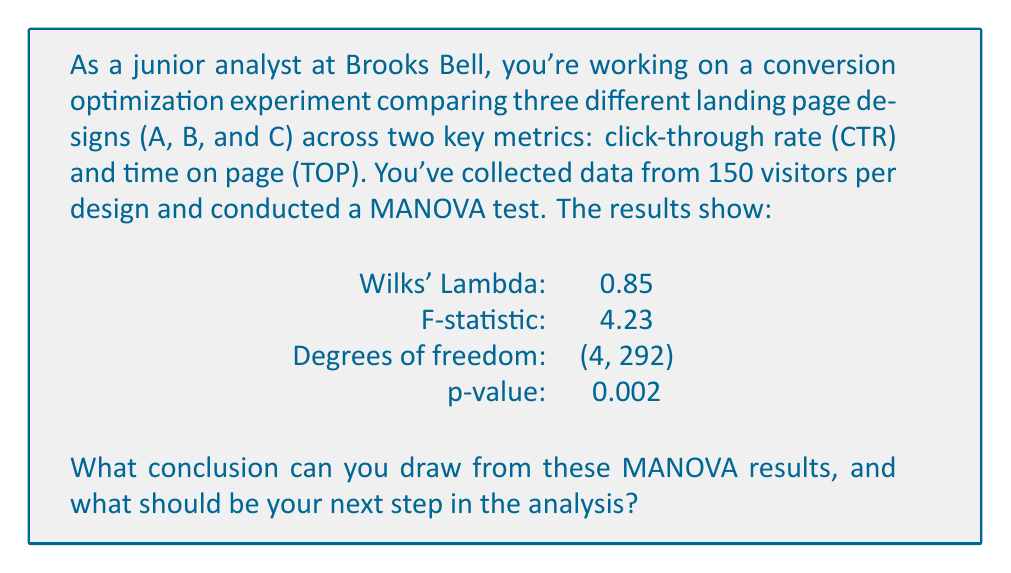Help me with this question. To interpret the MANOVA results, we need to understand each component:

1. Wilks' Lambda: This is a test statistic that ranges from 0 to 1. A value closer to 0 indicates greater differences between groups. Our value of 0.85 suggests some differences, but they may not be extremely large.

2. F-statistic: This is used to test the overall significance of the MANOVA. A larger F-value suggests greater differences between groups.

3. Degrees of freedom: These are (4, 292), which come from:
   - 4 = 2(k-1), where k = 3 (number of groups)
   - 292 = 2(N-k), where N = 150 * 3 = 450 (total sample size)

4. p-value: This is the probability of obtaining results as extreme as the observed results, assuming the null hypothesis is true. In this case, p = 0.002.

Interpretation:
The p-value (0.002) is less than the typical significance level of 0.05. This means we reject the null hypothesis that there are no differences among the three landing page designs across the two metrics (CTR and TOP) simultaneously.

Conclusion:
There are statistically significant differences among the three landing page designs when considering CTR and TOP together.

Next step:
Since the MANOVA revealed significant differences, the next step should be to conduct follow-up analyses to determine which specific groups differ and on which variables. This typically involves:

1. Univariate ANOVAs for each dependent variable (CTR and TOP) separately.
2. Post-hoc tests (e.g., Tukey's HSD) to identify which specific groups differ from each other on each variable.

These follow-up analyses will help pinpoint exactly where the differences lie, allowing for more targeted optimization of the landing page designs.
Answer: The MANOVA results (p = 0.002) indicate statistically significant differences among the three landing page designs across CTR and TOP. The next step is to conduct univariate ANOVAs and post-hoc tests to identify specific differences between groups and variables. 